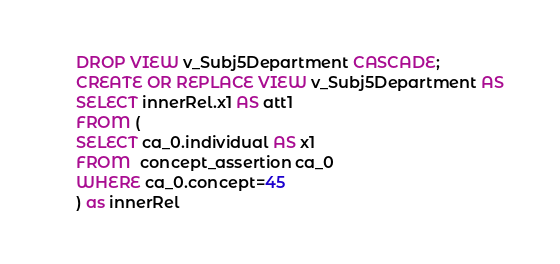<code> <loc_0><loc_0><loc_500><loc_500><_SQL_>DROP VIEW v_Subj5Department CASCADE;
CREATE OR REPLACE VIEW v_Subj5Department AS 
SELECT innerRel.x1 AS att1
FROM (
SELECT ca_0.individual AS x1
FROM  concept_assertion ca_0
WHERE ca_0.concept=45
) as innerRel
</code> 